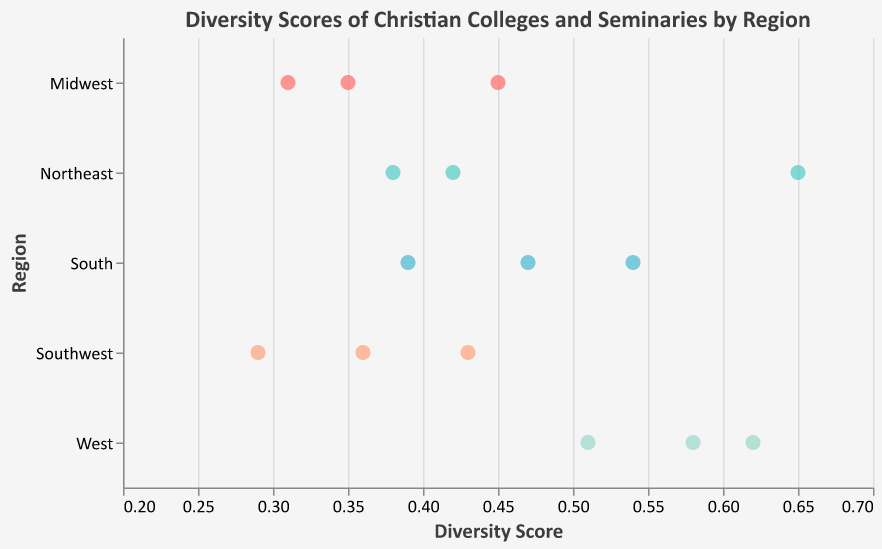What is the title of the plot? The title of the plot can be found at the top of the figure above the actual data points. The title is "Diversity Scores of Christian Colleges and Seminaries by Region"
Answer: Diversity Scores of Christian Colleges and Seminaries by Region Which region has the highest diversity score among its institutions? To determine the region with the highest diversity score, you need to identify the highest individual score among all regions listed. The West has the highest score with Azusa Pacific University's 0.62.
Answer: West What is the diversity score of Nyack College? To find the diversity score of Nyack College, look at the data points and tooltips in the figure. Nyack College, located in the Northeast, has a score of 0.65.
Answer: 0.65 How many institutions are plotted in the South region? To find the number of institutions in the South region, count the number of data points along the "South" row in the plot. There are three institutions.
Answer: 3 Which institution has the lowest diversity score in the Midwest region? To find the institution with the lowest score in the Midwest region, look at the data points for the Midwest and identify the one with the lowest value. Calvin University has the lowest score of 0.31.
Answer: Calvin University What is the average diversity score in the Southwest region? First, identify the diversity scores for the institutions in the Southwest region: 0.36, 0.43, and 0.29. Add these scores together (0.36 + 0.43 + 0.29 = 1.08) and then divide by the number of institutions (3). The average score is 1.08 / 3 = 0.36.
Answer: 0.36 Compare the diversity scores between Eastern Nazarene College and Dallas Theological Seminary. Which one has a higher score? Look at the diversity scores for both institutions. Eastern Nazarene College has a score of 0.38, while Dallas Theological Seminary has a score of 0.43. Thus, Dallas Theological Seminary has the higher score.
Answer: Dallas Theological Seminary Which institution in the West region has the median diversity score, and what is that score? In the West region, the diversity scores are 0.51, 0.58, and 0.62. When ordered from lowest to highest, the middle value (median) is 0.58, belonging to Biola University.
Answer: Biola University, 0.58 Is there any region where all institutions have a diversity score below 0.4? Review each region's diversity scores. In the Midwest, all institutions have scores of 0.35, 0.31, and 0.45, with Moody Bible Institute (0.45) being above 0.4, so this isn’t the answer. In the Southwest, institutions have scores of 0.36, 0.43, and 0.29, with Dallas Theological Seminary (0.43) being above 0.4. Thus, no region has all scores below 0.4.
Answer: No 